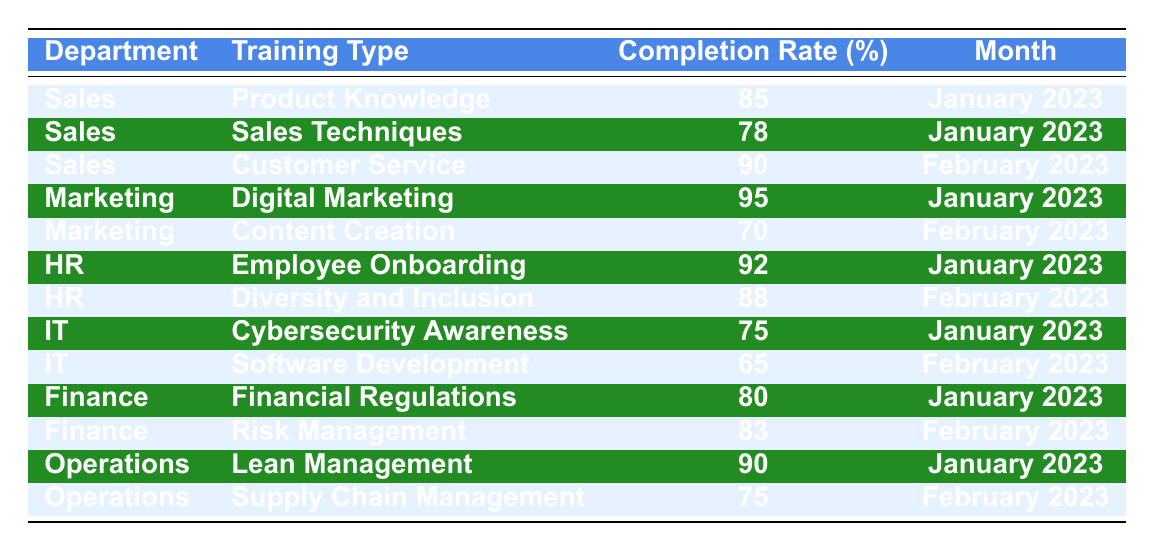What is the completion rate for Sales in January 2023 for Product Knowledge? The table shows the Completion Rate for the Sales department under "Product Knowledge" for January 2023 is 85%.
Answer: 85 Which department had the highest training completion rate in January 2023? Looking at the table, Marketing's Digital Marketing training had the highest rate of 95% in January 2023.
Answer: Marketing What was the completion rate difference between HR's trainings in January and February 2023? HR's Employee Onboarding had a completion rate of 92% in January, while Diversity and Inclusion had 88% in February. The difference is 92 - 88 = 4%.
Answer: 4% Is the completion rate for IT's Software Development lower than the average completion rate for the Sales department's trainings in February 2023? Sales had a completion rate of 90% for Customer Service and 78% for Sales Techniques in February 2023, averaging (90 + 78) / 2 = 84%. The Software Development completion rate is 65%, which is lower than 84%.
Answer: Yes What is the average training completion rate for the Finance department across both months? The Finance department had a completion rate of 80% in January and 83% in February. The average is (80 + 83) / 2 = 81.5%.
Answer: 81.5 Which training type in February 2023 had the lowest completion rate? The table shows that IT's Software Development had the lowest completion rate of 65% in February 2023.
Answer: Software Development Did the Operations department improve its training completion rate from January to February 2023? Operations had a completion rate of 90% for Lean Management in January and 75% for Supply Chain Management in February. This indicates a decrease from January to February.
Answer: No What was the combined completion rate for all departments in January 2023? By summing completion rates: Sales (85) + Marketing (95) + HR (92) + IT (75) + Finance (80) + Operations (90) = 517%. To find the combined rate, divide by the number of departments (6): 517 / 6 = 86.17%.
Answer: 86.17 Which department had the highest overall completion rate across all trainings in January 2023? The best completion rate in January is from Marketing (95%), thus they had the highest overall completion rate across all trainings for that month.
Answer: Marketing Was there any department that recorded a completion rate of 70% or lower in the training types? Yes, Marketing's Content Creation training recorded a completion rate of 70% in February 2023.
Answer: Yes What is the trend in training completion rates for the IT department from January to February 2023? IT's completion rates decreased from 75% in January for Cybersecurity Awareness to 65% in February for Software Development, indicating a negative trend.
Answer: Decrease 